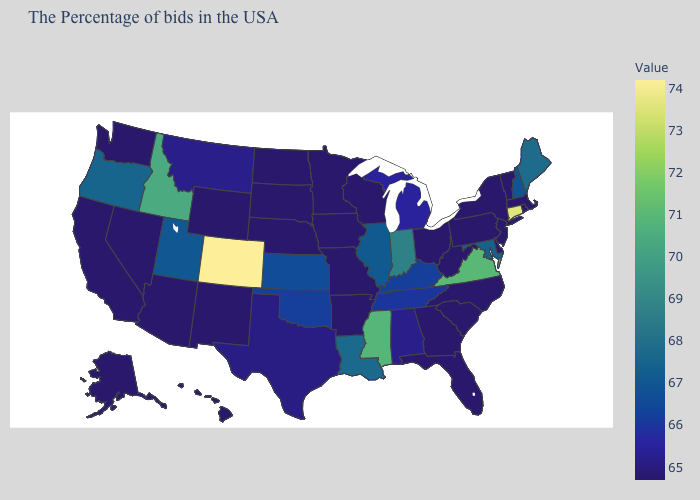Does New Jersey have the lowest value in the Northeast?
Be succinct. Yes. Among the states that border Nevada , which have the highest value?
Write a very short answer. Idaho. Does the map have missing data?
Write a very short answer. No. Does New Mexico have the highest value in the USA?
Quick response, please. No. Which states have the lowest value in the Northeast?
Concise answer only. Massachusetts, Rhode Island, Vermont, New York, New Jersey, Pennsylvania. Among the states that border California , does Nevada have the highest value?
Quick response, please. No. 